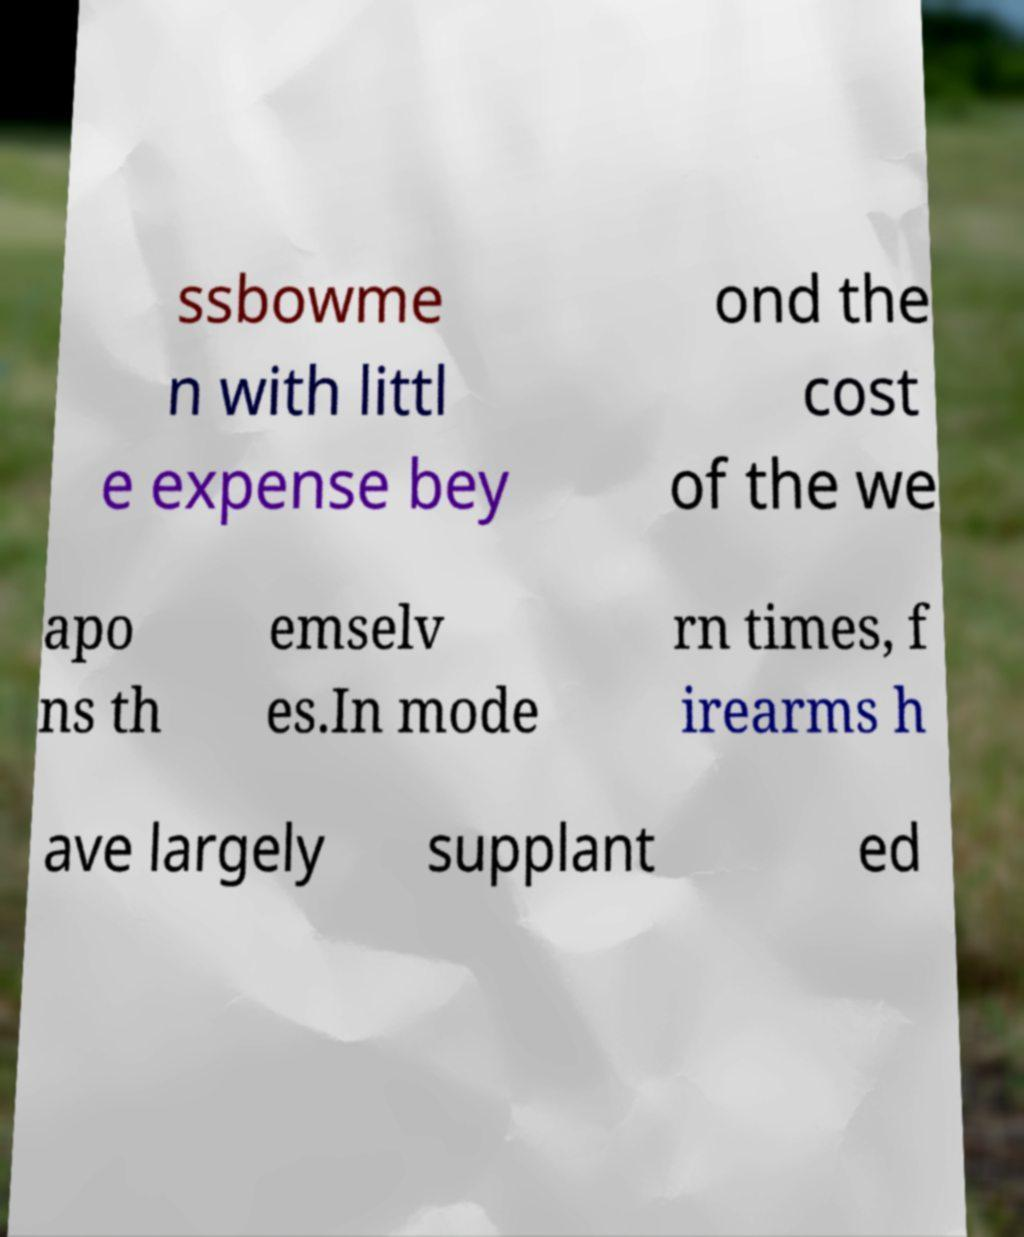Please read and relay the text visible in this image. What does it say? ssbowme n with littl e expense bey ond the cost of the we apo ns th emselv es.In mode rn times, f irearms h ave largely supplant ed 